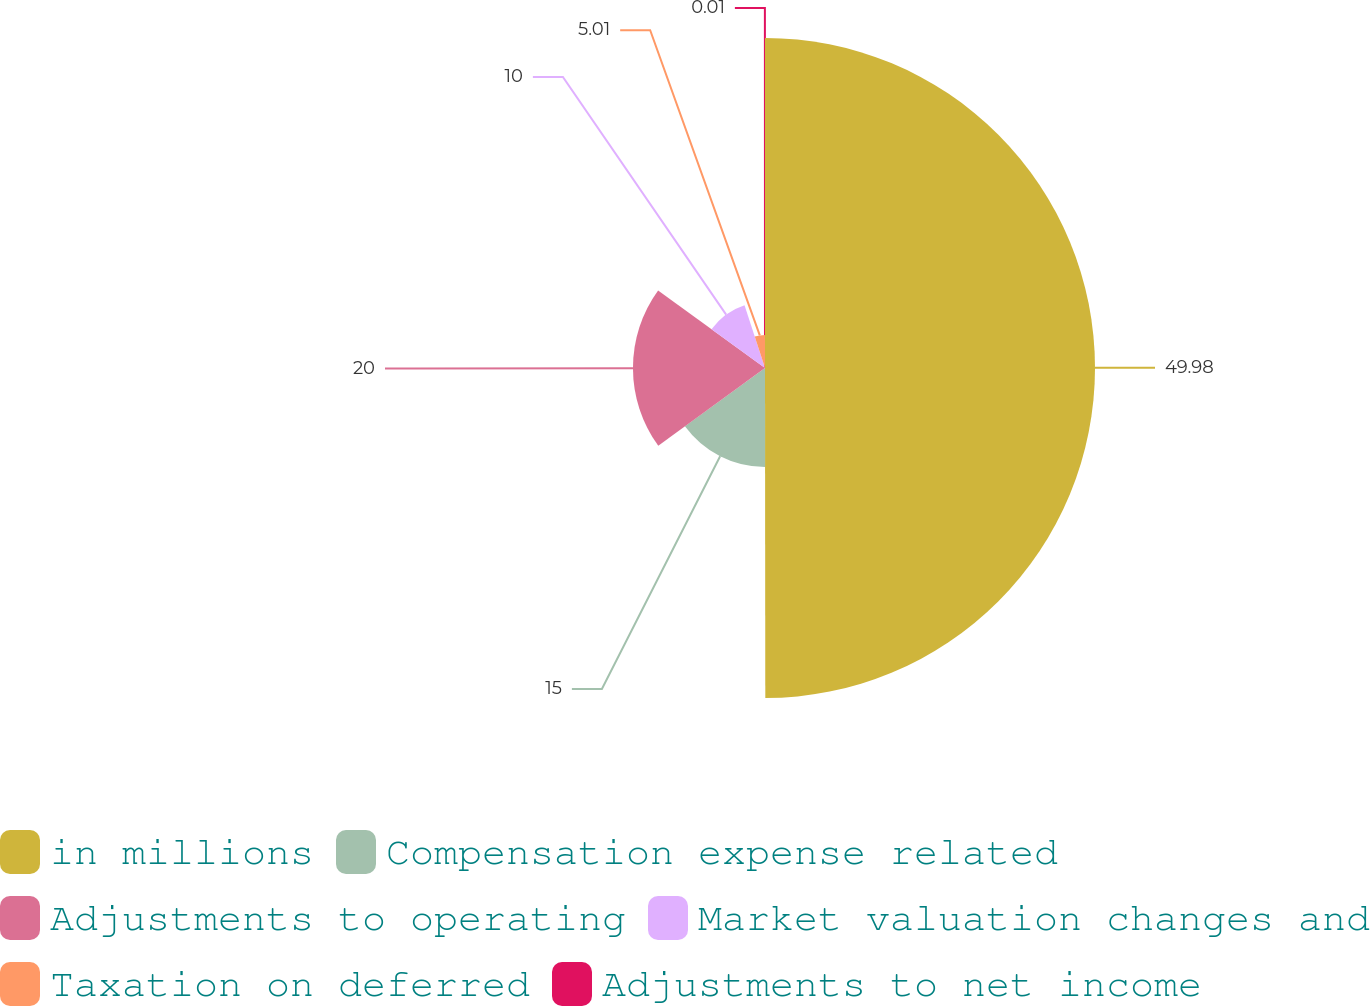<chart> <loc_0><loc_0><loc_500><loc_500><pie_chart><fcel>in millions<fcel>Compensation expense related<fcel>Adjustments to operating<fcel>Market valuation changes and<fcel>Taxation on deferred<fcel>Adjustments to net income<nl><fcel>49.99%<fcel>15.0%<fcel>20.0%<fcel>10.0%<fcel>5.01%<fcel>0.01%<nl></chart> 